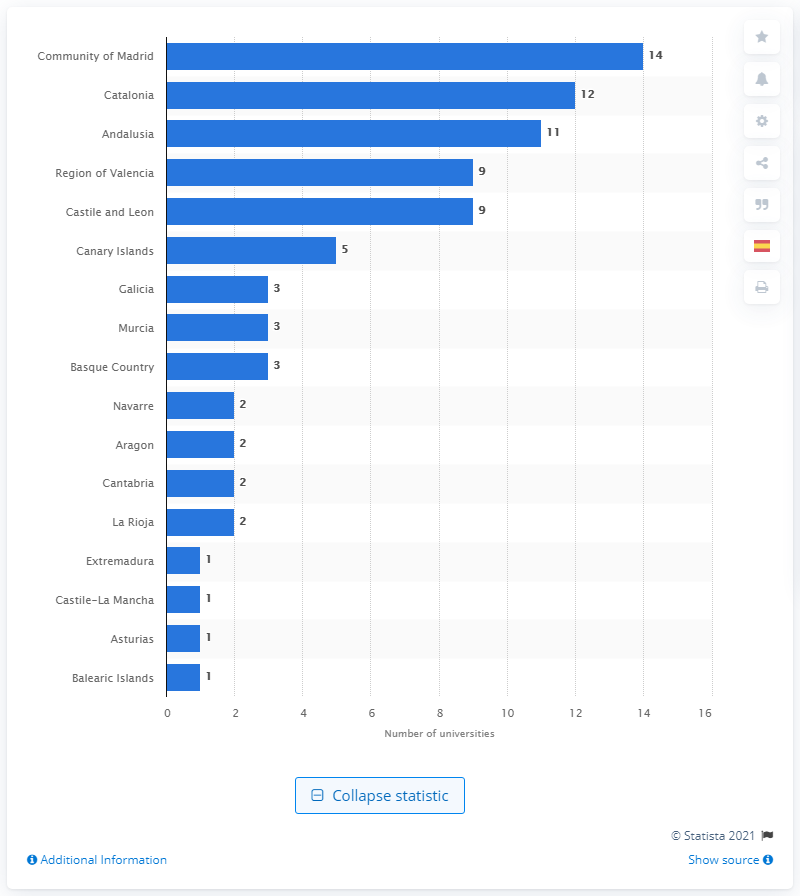Highlight a few significant elements in this photo. In the academic year 2019/2020, the Community of Madrid had a total of 14 universities. In the academic year 2019/2020, Catalonia had 12 universities. 